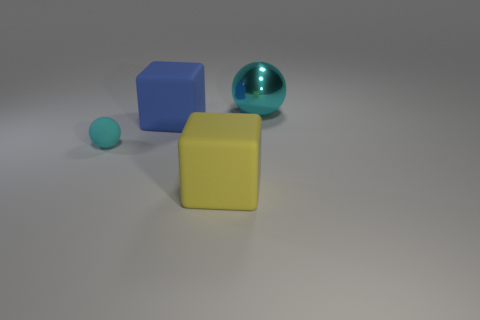Can you tell me about the shapes and colors present in this image? Certainly! The image showcases a collection of three objects, each with distinct shapes and colors. There's a blue cube, which has a solid and even-toned appearance, a metallic sphere with a reflective surface that slightly mirrors its environment, and a small cyan sphere with a similar texture to the cube. There's also a larger yellow cube, slightly occluded by the blue one, sharing the same matte finish. 